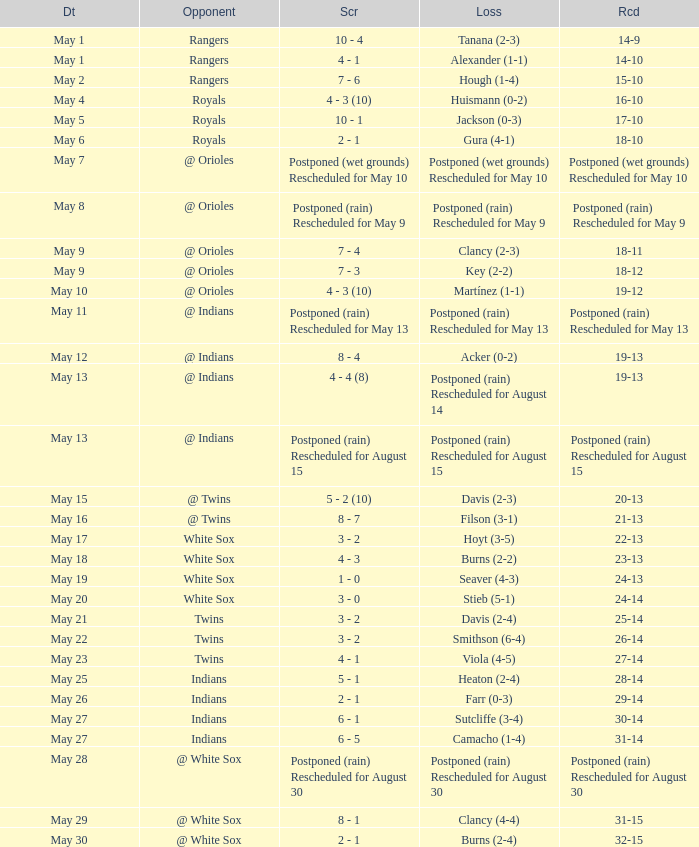Which team was competing when the game's record showed 22-13? White Sox. 